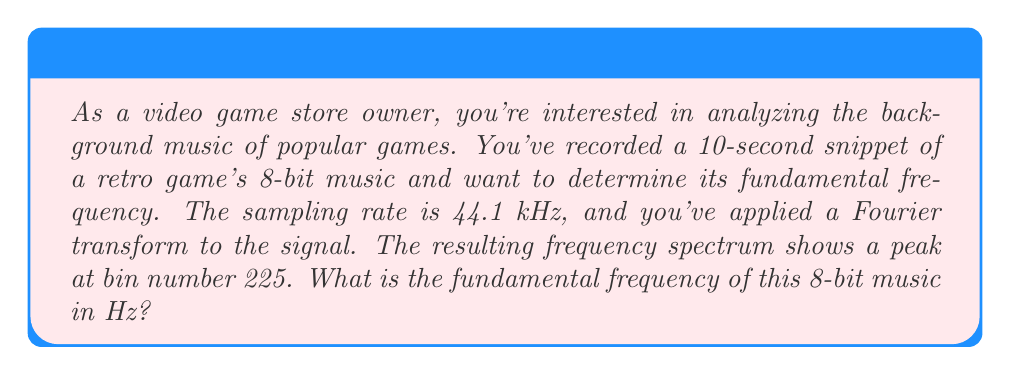Could you help me with this problem? To solve this problem, we need to understand the relationship between the Fourier transform bin numbers and the actual frequencies. Let's break it down step-by-step:

1) First, we need to calculate the frequency resolution of our spectrum. This is given by:

   $$\Delta f = \frac{f_s}{N}$$

   Where $f_s$ is the sampling rate and $N$ is the number of samples.

2) We know $f_s = 44100$ Hz, and we have a 10-second snippet. So:

   $N = 44100 \times 10 = 441000$ samples

3) Now we can calculate $\Delta f$:

   $$\Delta f = \frac{44100}{441000} = 0.1 \text{ Hz}$$

4) The frequency corresponding to any bin number $k$ is given by:

   $$f = k \times \Delta f$$

5) We're told the peak is at bin number 225. So:

   $$f = 225 \times 0.1 = 22.5 \text{ Hz}$$

This frequency of 22.5 Hz is characteristic of the low tones often found in 8-bit music, which fits with the retro game context.
Answer: The fundamental frequency of the 8-bit music is 22.5 Hz. 